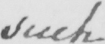Please provide the text content of this handwritten line. such 